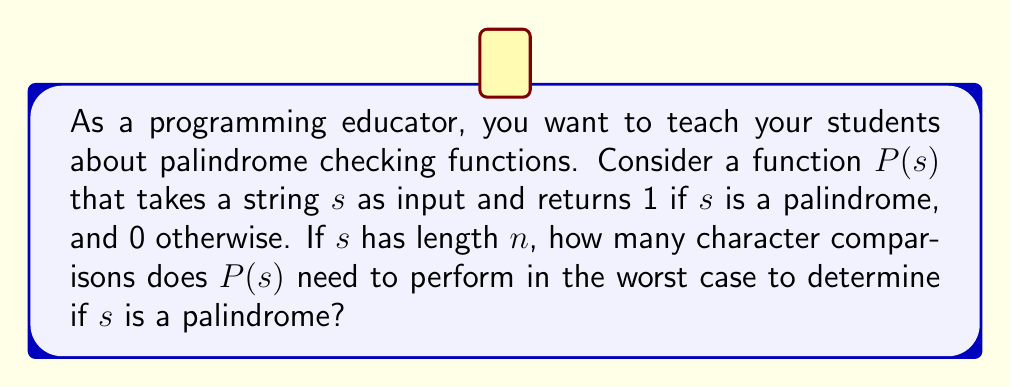Give your solution to this math problem. To determine if a string is a palindrome, we need to compare characters from both ends of the string, moving towards the center. Let's break down the process:

1) For a string of length $n$, we start by comparing the first and last characters:
   $s[0]$ with $s[n-1]$

2) If they match, we move inwards and compare the second and second-to-last characters:
   $s[1]$ with $s[n-2]$

3) We continue this process until we reach the middle of the string.

4) In the worst case (when the string is a palindrome or almost a palindrome), we need to compare pairs of characters until we reach the middle of the string.

5) The number of comparisons needed is equal to half the length of the string, rounded down:
   $$\left\lfloor\frac{n}{2}\right\rfloor$$

6) This is because for odd-length strings, the middle character doesn't need to be compared with anything.

Therefore, in the worst case, the function $P(s)$ needs to perform $\left\lfloor\frac{n}{2}\right\rfloor$ character comparisons to determine if $s$ is a palindrome.
Answer: $\left\lfloor\frac{n}{2}\right\rfloor$ 